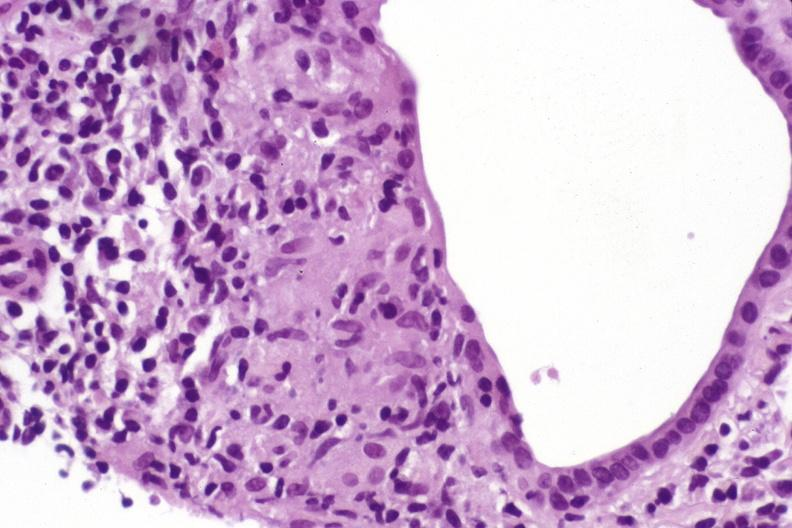what is present?
Answer the question using a single word or phrase. Liver 